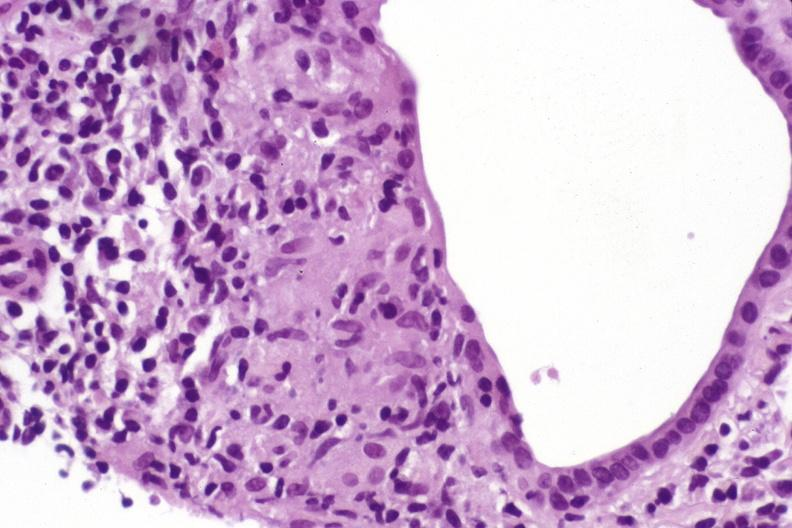what is present?
Answer the question using a single word or phrase. Liver 